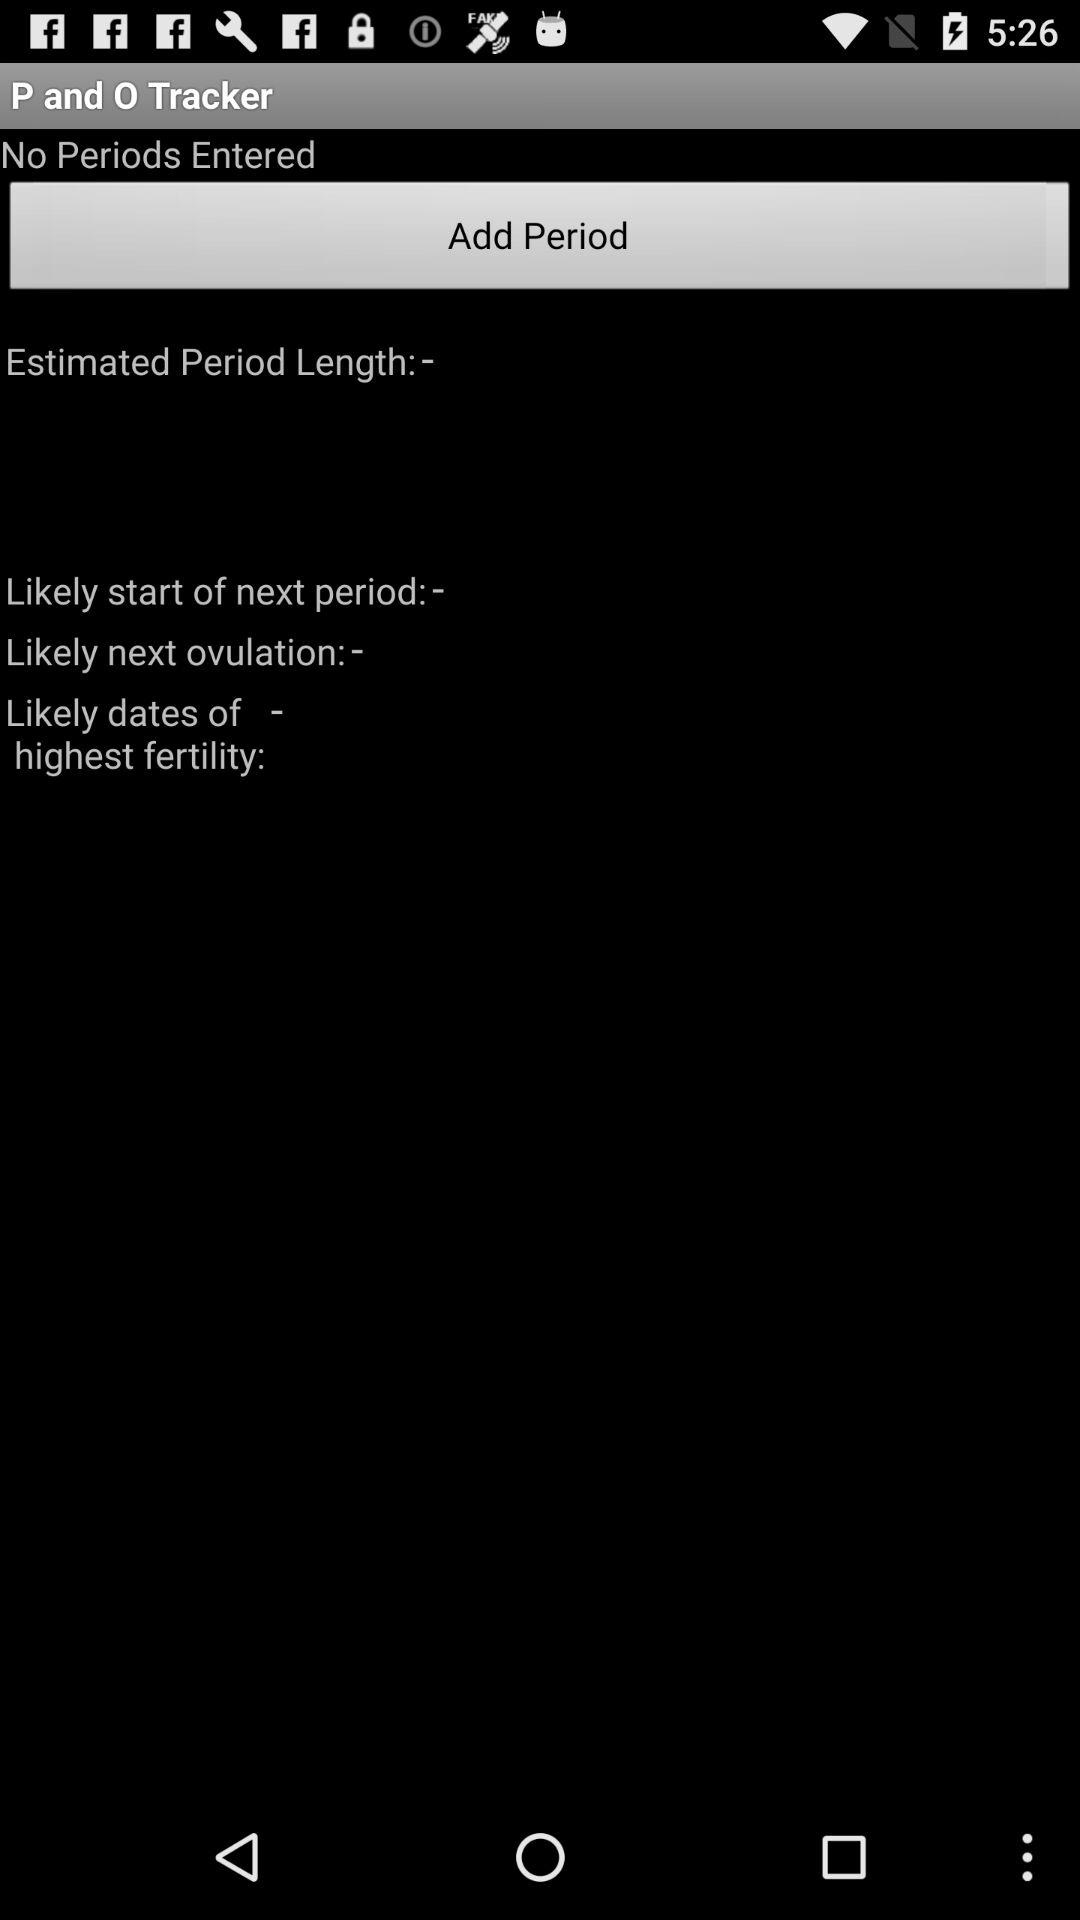Is there any entered period? There is no entered period. 